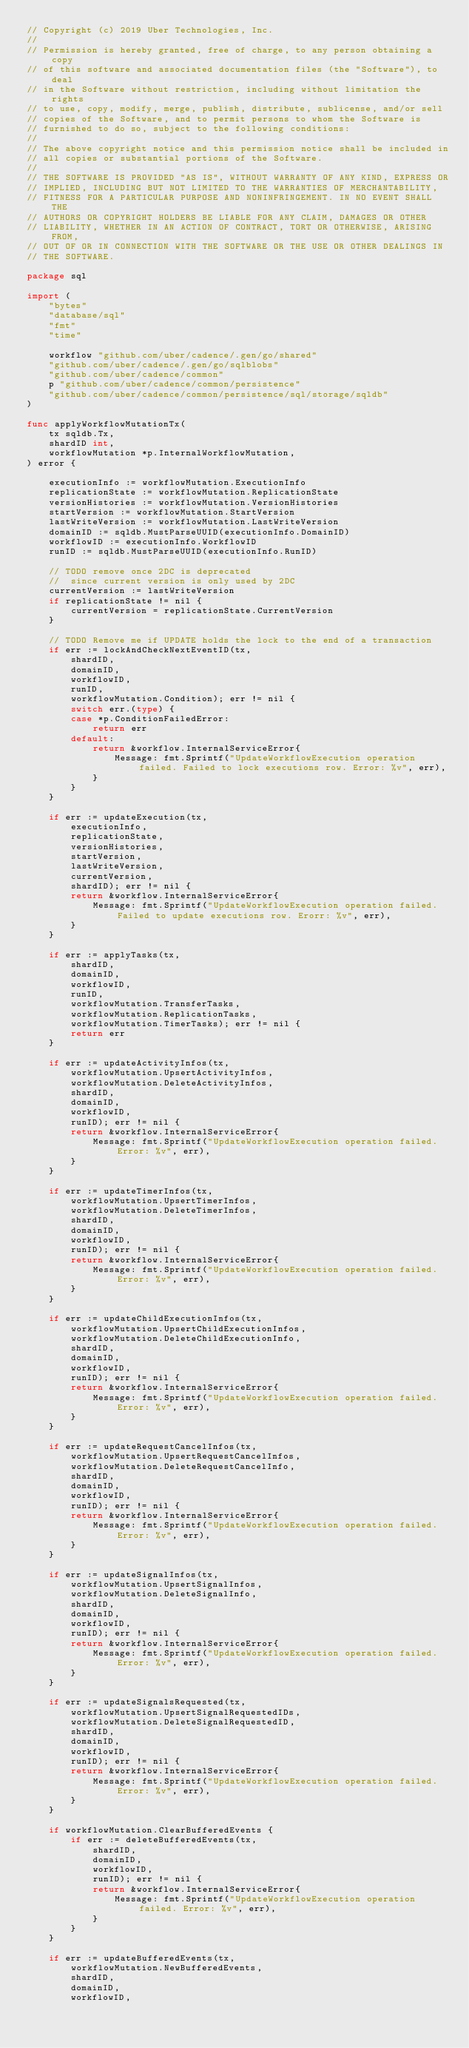<code> <loc_0><loc_0><loc_500><loc_500><_Go_>// Copyright (c) 2019 Uber Technologies, Inc.
//
// Permission is hereby granted, free of charge, to any person obtaining a copy
// of this software and associated documentation files (the "Software"), to deal
// in the Software without restriction, including without limitation the rights
// to use, copy, modify, merge, publish, distribute, sublicense, and/or sell
// copies of the Software, and to permit persons to whom the Software is
// furnished to do so, subject to the following conditions:
//
// The above copyright notice and this permission notice shall be included in
// all copies or substantial portions of the Software.
//
// THE SOFTWARE IS PROVIDED "AS IS", WITHOUT WARRANTY OF ANY KIND, EXPRESS OR
// IMPLIED, INCLUDING BUT NOT LIMITED TO THE WARRANTIES OF MERCHANTABILITY,
// FITNESS FOR A PARTICULAR PURPOSE AND NONINFRINGEMENT. IN NO EVENT SHALL THE
// AUTHORS OR COPYRIGHT HOLDERS BE LIABLE FOR ANY CLAIM, DAMAGES OR OTHER
// LIABILITY, WHETHER IN AN ACTION OF CONTRACT, TORT OR OTHERWISE, ARISING FROM,
// OUT OF OR IN CONNECTION WITH THE SOFTWARE OR THE USE OR OTHER DEALINGS IN
// THE SOFTWARE.

package sql

import (
	"bytes"
	"database/sql"
	"fmt"
	"time"

	workflow "github.com/uber/cadence/.gen/go/shared"
	"github.com/uber/cadence/.gen/go/sqlblobs"
	"github.com/uber/cadence/common"
	p "github.com/uber/cadence/common/persistence"
	"github.com/uber/cadence/common/persistence/sql/storage/sqldb"
)

func applyWorkflowMutationTx(
	tx sqldb.Tx,
	shardID int,
	workflowMutation *p.InternalWorkflowMutation,
) error {

	executionInfo := workflowMutation.ExecutionInfo
	replicationState := workflowMutation.ReplicationState
	versionHistories := workflowMutation.VersionHistories
	startVersion := workflowMutation.StartVersion
	lastWriteVersion := workflowMutation.LastWriteVersion
	domainID := sqldb.MustParseUUID(executionInfo.DomainID)
	workflowID := executionInfo.WorkflowID
	runID := sqldb.MustParseUUID(executionInfo.RunID)

	// TODO remove once 2DC is deprecated
	//  since current version is only used by 2DC
	currentVersion := lastWriteVersion
	if replicationState != nil {
		currentVersion = replicationState.CurrentVersion
	}

	// TODO Remove me if UPDATE holds the lock to the end of a transaction
	if err := lockAndCheckNextEventID(tx,
		shardID,
		domainID,
		workflowID,
		runID,
		workflowMutation.Condition); err != nil {
		switch err.(type) {
		case *p.ConditionFailedError:
			return err
		default:
			return &workflow.InternalServiceError{
				Message: fmt.Sprintf("UpdateWorkflowExecution operation failed. Failed to lock executions row. Error: %v", err),
			}
		}
	}

	if err := updateExecution(tx,
		executionInfo,
		replicationState,
		versionHistories,
		startVersion,
		lastWriteVersion,
		currentVersion,
		shardID); err != nil {
		return &workflow.InternalServiceError{
			Message: fmt.Sprintf("UpdateWorkflowExecution operation failed. Failed to update executions row. Erorr: %v", err),
		}
	}

	if err := applyTasks(tx,
		shardID,
		domainID,
		workflowID,
		runID,
		workflowMutation.TransferTasks,
		workflowMutation.ReplicationTasks,
		workflowMutation.TimerTasks); err != nil {
		return err
	}

	if err := updateActivityInfos(tx,
		workflowMutation.UpsertActivityInfos,
		workflowMutation.DeleteActivityInfos,
		shardID,
		domainID,
		workflowID,
		runID); err != nil {
		return &workflow.InternalServiceError{
			Message: fmt.Sprintf("UpdateWorkflowExecution operation failed. Error: %v", err),
		}
	}

	if err := updateTimerInfos(tx,
		workflowMutation.UpsertTimerInfos,
		workflowMutation.DeleteTimerInfos,
		shardID,
		domainID,
		workflowID,
		runID); err != nil {
		return &workflow.InternalServiceError{
			Message: fmt.Sprintf("UpdateWorkflowExecution operation failed. Error: %v", err),
		}
	}

	if err := updateChildExecutionInfos(tx,
		workflowMutation.UpsertChildExecutionInfos,
		workflowMutation.DeleteChildExecutionInfo,
		shardID,
		domainID,
		workflowID,
		runID); err != nil {
		return &workflow.InternalServiceError{
			Message: fmt.Sprintf("UpdateWorkflowExecution operation failed. Error: %v", err),
		}
	}

	if err := updateRequestCancelInfos(tx,
		workflowMutation.UpsertRequestCancelInfos,
		workflowMutation.DeleteRequestCancelInfo,
		shardID,
		domainID,
		workflowID,
		runID); err != nil {
		return &workflow.InternalServiceError{
			Message: fmt.Sprintf("UpdateWorkflowExecution operation failed. Error: %v", err),
		}
	}

	if err := updateSignalInfos(tx,
		workflowMutation.UpsertSignalInfos,
		workflowMutation.DeleteSignalInfo,
		shardID,
		domainID,
		workflowID,
		runID); err != nil {
		return &workflow.InternalServiceError{
			Message: fmt.Sprintf("UpdateWorkflowExecution operation failed. Error: %v", err),
		}
	}

	if err := updateSignalsRequested(tx,
		workflowMutation.UpsertSignalRequestedIDs,
		workflowMutation.DeleteSignalRequestedID,
		shardID,
		domainID,
		workflowID,
		runID); err != nil {
		return &workflow.InternalServiceError{
			Message: fmt.Sprintf("UpdateWorkflowExecution operation failed. Error: %v", err),
		}
	}

	if workflowMutation.ClearBufferedEvents {
		if err := deleteBufferedEvents(tx,
			shardID,
			domainID,
			workflowID,
			runID); err != nil {
			return &workflow.InternalServiceError{
				Message: fmt.Sprintf("UpdateWorkflowExecution operation failed. Error: %v", err),
			}
		}
	}

	if err := updateBufferedEvents(tx,
		workflowMutation.NewBufferedEvents,
		shardID,
		domainID,
		workflowID,</code> 